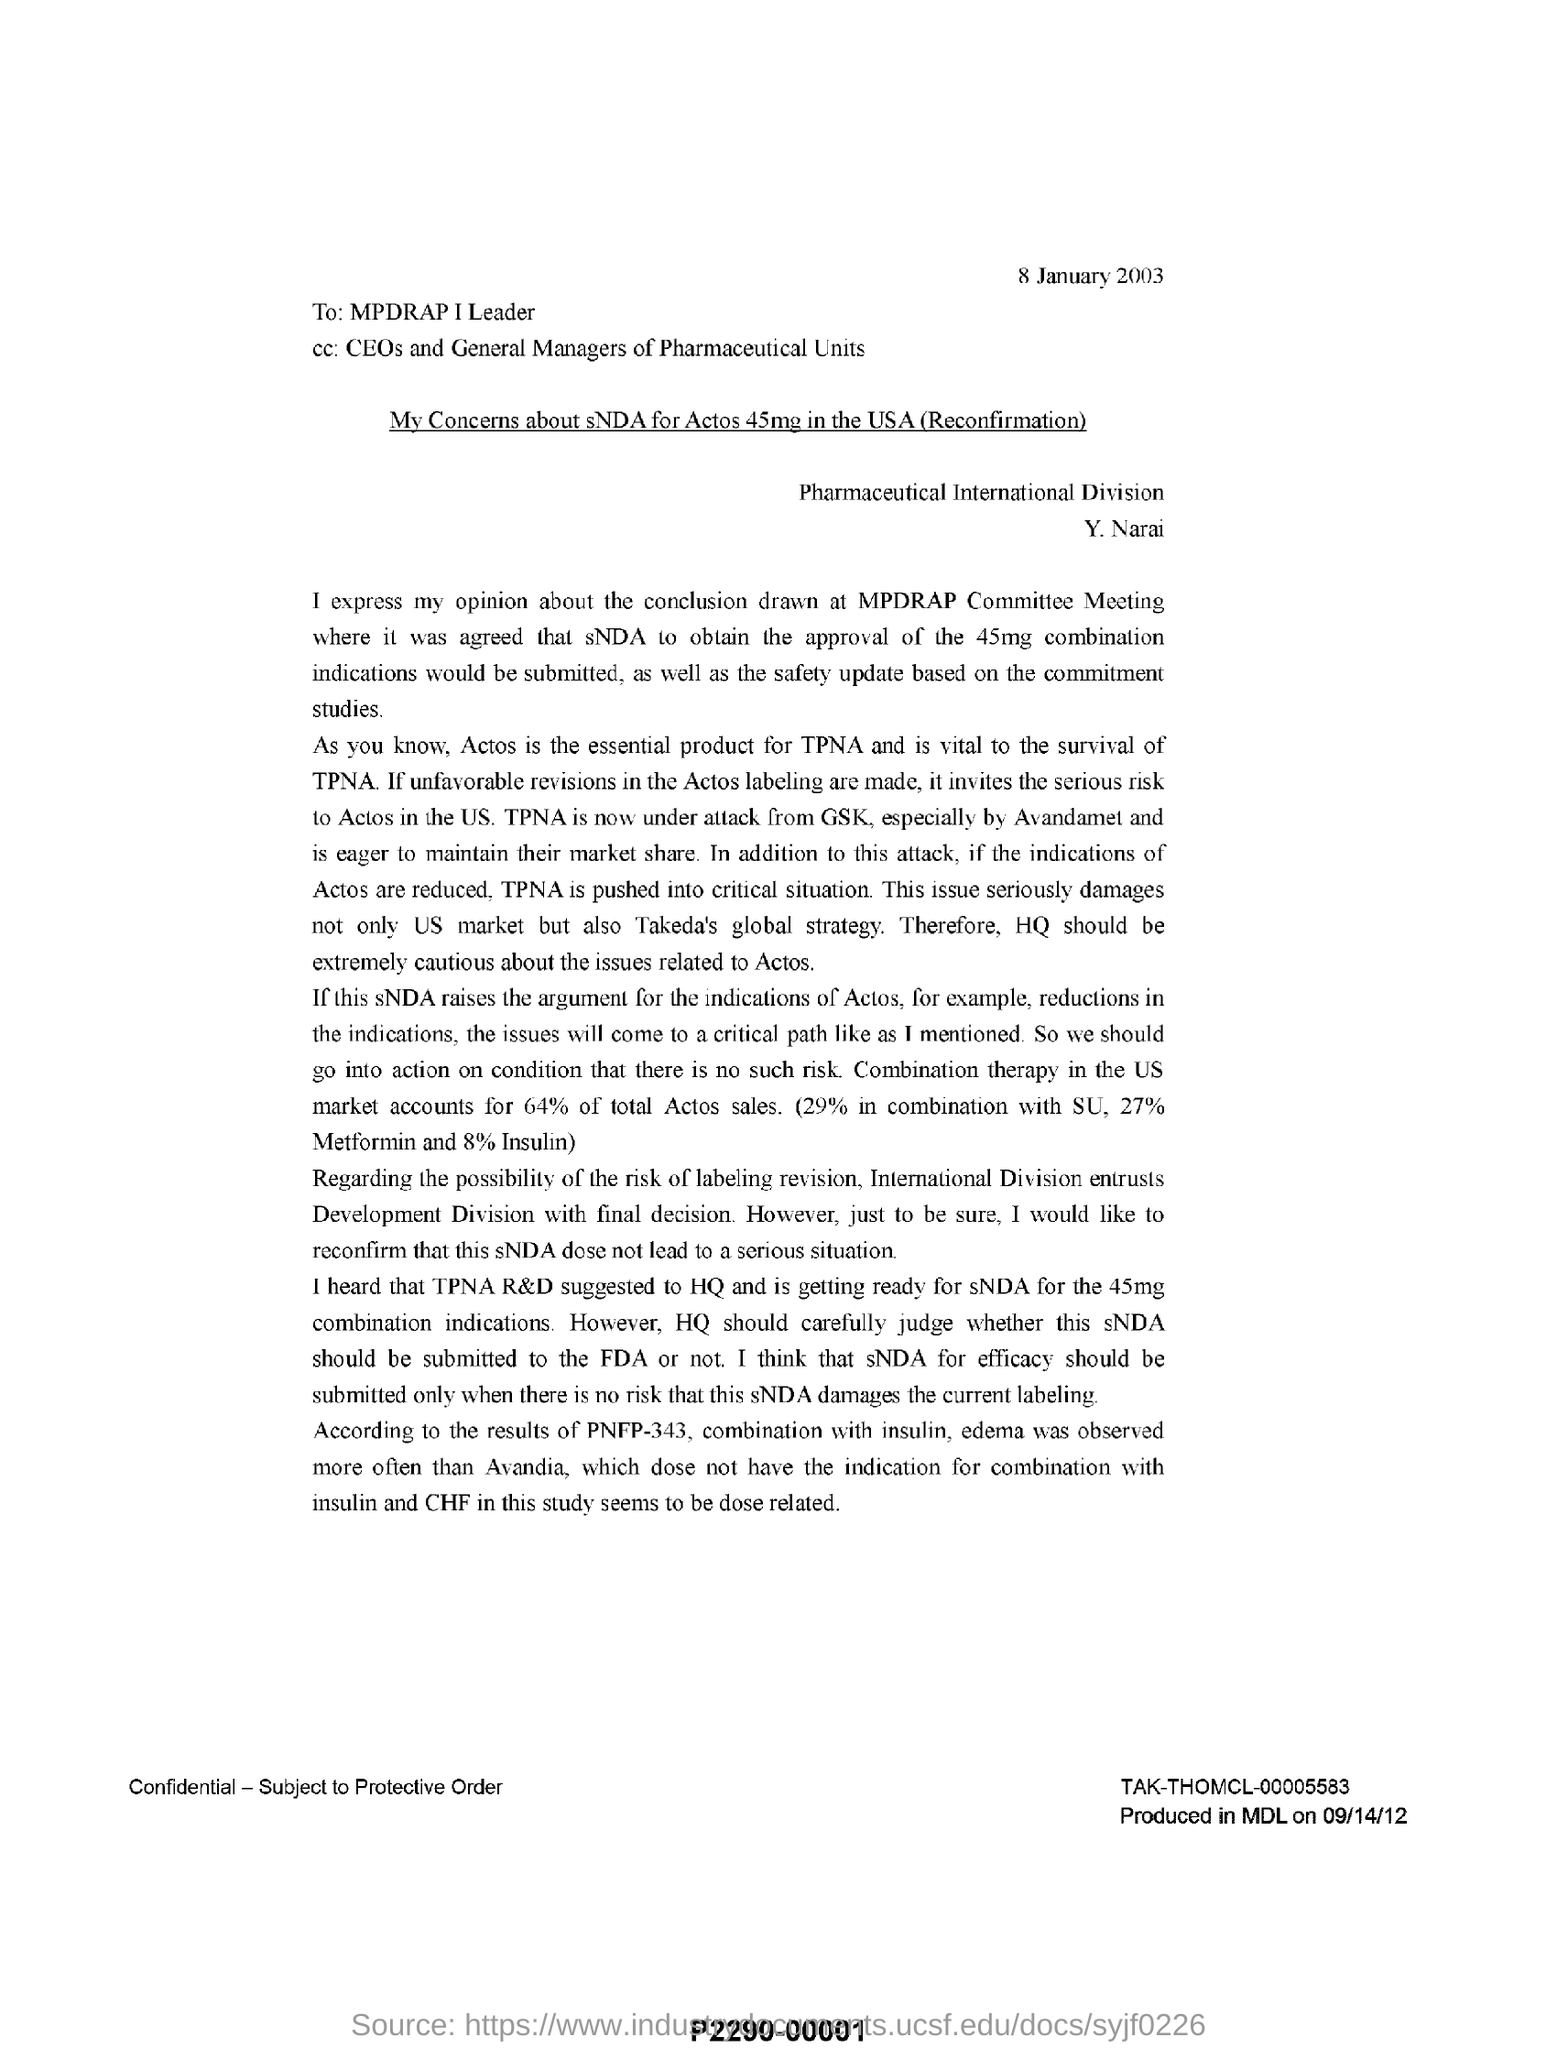What is the date mentioned in the  letter
Ensure brevity in your answer.  8 january 2003. To whom this letter is addressed?
Give a very brief answer. MPDRAP I Leader. What is mentioned in the cc?
Your answer should be very brief. CEOs and General Managers of Pharmaceutical Units. Combination therapy in the us market accounts for how much % of total actos sales .
Make the answer very short. 64. 